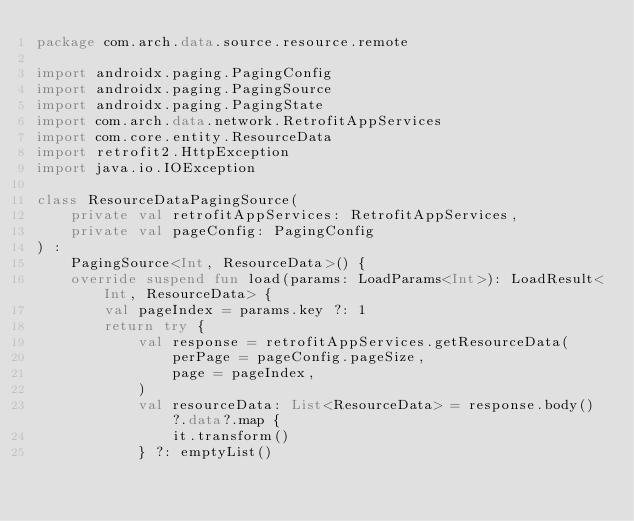Convert code to text. <code><loc_0><loc_0><loc_500><loc_500><_Kotlin_>package com.arch.data.source.resource.remote

import androidx.paging.PagingConfig
import androidx.paging.PagingSource
import androidx.paging.PagingState
import com.arch.data.network.RetrofitAppServices
import com.core.entity.ResourceData
import retrofit2.HttpException
import java.io.IOException

class ResourceDataPagingSource(
    private val retrofitAppServices: RetrofitAppServices,
    private val pageConfig: PagingConfig
) :
    PagingSource<Int, ResourceData>() {
    override suspend fun load(params: LoadParams<Int>): LoadResult<Int, ResourceData> {
        val pageIndex = params.key ?: 1
        return try {
            val response = retrofitAppServices.getResourceData(
                perPage = pageConfig.pageSize,
                page = pageIndex,
            )
            val resourceData: List<ResourceData> = response.body()?.data?.map {
                it.transform()
            } ?: emptyList()</code> 